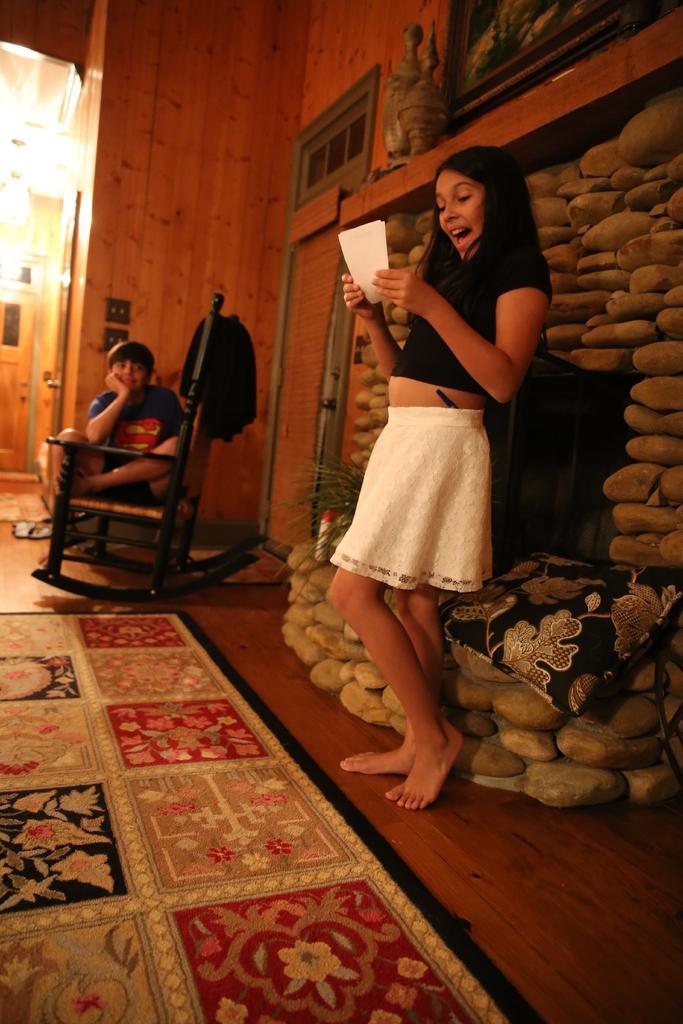In one or two sentences, can you explain what this image depicts? In the picture I can see a woman wearing black and white color dress standing near the wall holding some paper in her hands and in the background of the picture there is a kid wearing blue color dress sitting on a chair and there is a wall. 